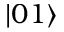<formula> <loc_0><loc_0><loc_500><loc_500>| 0 1 \rangle</formula> 